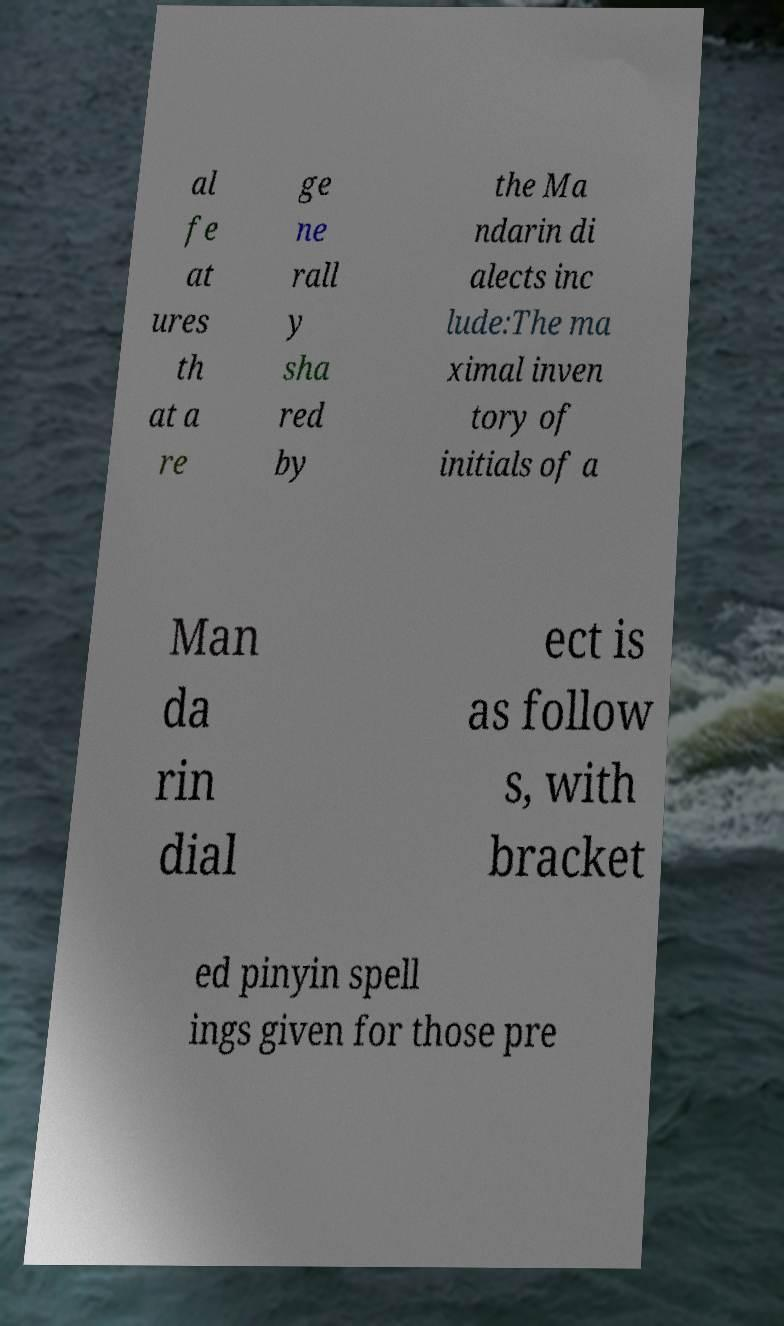Can you accurately transcribe the text from the provided image for me? al fe at ures th at a re ge ne rall y sha red by the Ma ndarin di alects inc lude:The ma ximal inven tory of initials of a Man da rin dial ect is as follow s, with bracket ed pinyin spell ings given for those pre 